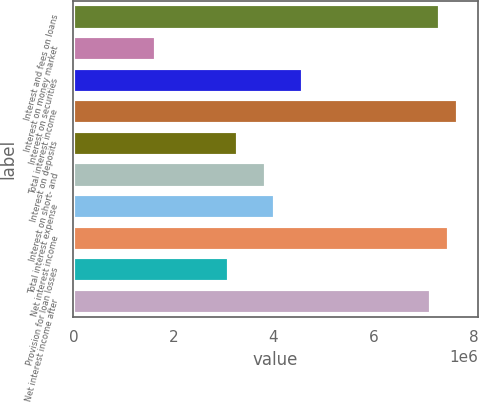Convert chart to OTSL. <chart><loc_0><loc_0><loc_500><loc_500><bar_chart><fcel>Interest and fees on loans<fcel>Interest on money market<fcel>Interest on securities<fcel>Total interest income<fcel>Interest on deposits<fcel>Interest on short- and<fcel>Total interest expense<fcel>Net interest income<fcel>Provision for loan losses<fcel>Net interest income after<nl><fcel>7.33388e+06<fcel>1.65012e+06<fcel>4.58368e+06<fcel>7.70057e+06<fcel>3.30025e+06<fcel>3.85029e+06<fcel>4.03363e+06<fcel>7.51723e+06<fcel>3.1169e+06<fcel>7.15053e+06<nl></chart> 